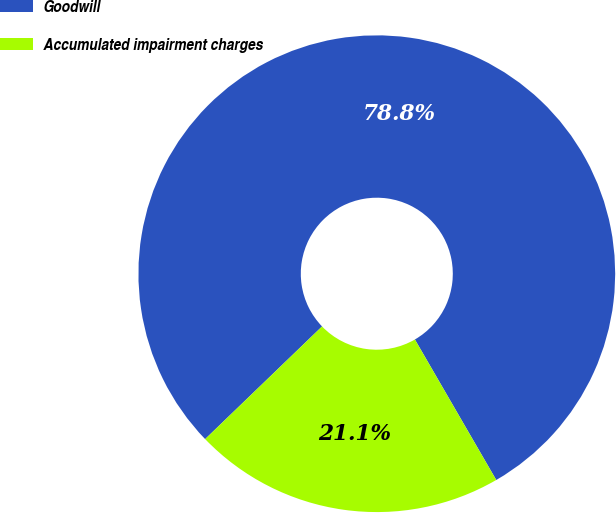Convert chart to OTSL. <chart><loc_0><loc_0><loc_500><loc_500><pie_chart><fcel>Goodwill<fcel>Accumulated impairment charges<nl><fcel>78.85%<fcel>21.15%<nl></chart> 